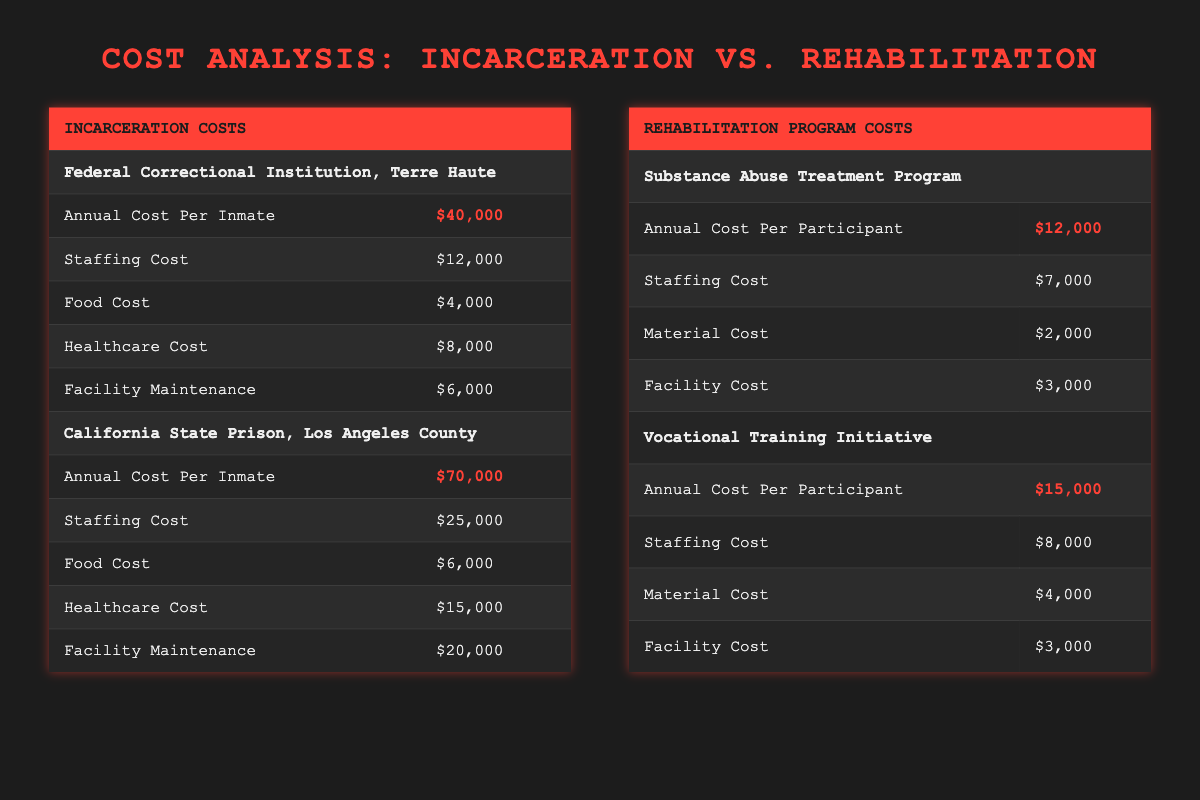What is the annual cost per inmate at the Federal Correctional Institution, Terre Haute? The table indicates the annual cost per inmate at this facility is listed under "Incarceration Costs," where it states $40,000.
Answer: 40,000 What is the total staffing cost for the California State Prison, Los Angeles County? The staffing cost for this prison can be found in the "Incarceration Costs" table under its section, which shows $25,000.
Answer: 25,000 Which rehabilitation program has the highest annual cost per participant? By comparing the annual costs per participant in the Rehabilitation Programs section, the Vocational Training Initiative shows $15,000, while the Substance Abuse Treatment Program shows $12,000. Thus, the highest is $15,000.
Answer: 15,000 What is the combined annual cost per participant for both rehabilitation programs? For both programs, add the values: $12,000 (Substance Abuse Treatment Program) + $15,000 (Vocational Training Initiative) = $27,000.
Answer: 27,000 Is the combined food cost for both incarceration facilities greater than the annual cost per participant for both rehabilitation programs? The food cost for Terre Haute is $4,000, and for Los Angeles County, it's $6,000. Combined, this equals $10,000. The total annual cost per participant for rehabilitation programs is $27,000. Since $10,000 is less than $27,000, the answer is no.
Answer: No What is the total healthcare cost combined for both incarceration facilities? Add the healthcare costs: $8,000 (Terre Haute) + $15,000 (Los Angeles County) = $23,000.
Answer: 23,000 Are the staffing costs for both rehabilitation programs less than the staffing cost for the California State Prison, Los Angeles County? The staffing cost for both programs is $7,000 (Substance Abuse) + $8,000 (Vocational Training) = $15,000. The staffing cost for the California State Prison is $25,000. Since $15,000 is less than $25,000, the answer is yes.
Answer: Yes What is the difference in annual cost per inmate between the two incarceration facilities? Calculate the difference: $70,000 (California State Prison) - $40,000 (Terre Haute) = $30,000.
Answer: 30,000 Which facility has the highest annual cost per inmate, and what is that cost? The California State Prison, Los Angeles County, has the highest annual cost per inmate at $70,000 listed under Incarceration Costs.
Answer: 70,000 